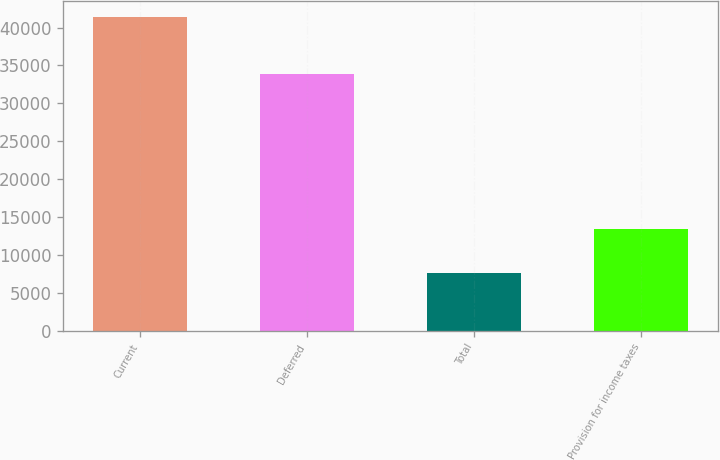Convert chart. <chart><loc_0><loc_0><loc_500><loc_500><bar_chart><fcel>Current<fcel>Deferred<fcel>Total<fcel>Provision for income taxes<nl><fcel>41425<fcel>33819<fcel>7606<fcel>13372<nl></chart> 